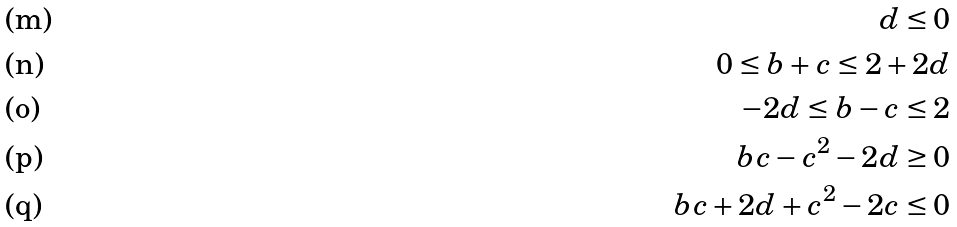Convert formula to latex. <formula><loc_0><loc_0><loc_500><loc_500>d \leq 0 \\ 0 \leq b + c \leq 2 + 2 d \\ - 2 d \leq b - c \leq 2 \\ b c - c ^ { 2 } - 2 d \geq 0 \\ b c + 2 d + c ^ { 2 } - 2 c \leq 0</formula> 